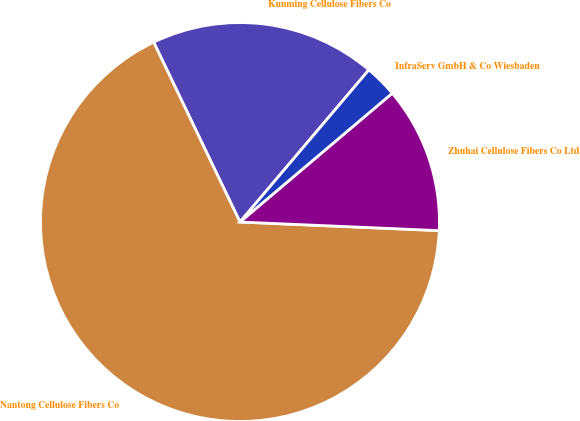Convert chart. <chart><loc_0><loc_0><loc_500><loc_500><pie_chart><fcel>Kunming Cellulose Fibers Co<fcel>Nantong Cellulose Fibers Co<fcel>Zhuhai Cellulose Fibers Co Ltd<fcel>InfraServ GmbH & Co Wiesbaden<nl><fcel>18.31%<fcel>67.19%<fcel>11.86%<fcel>2.64%<nl></chart> 